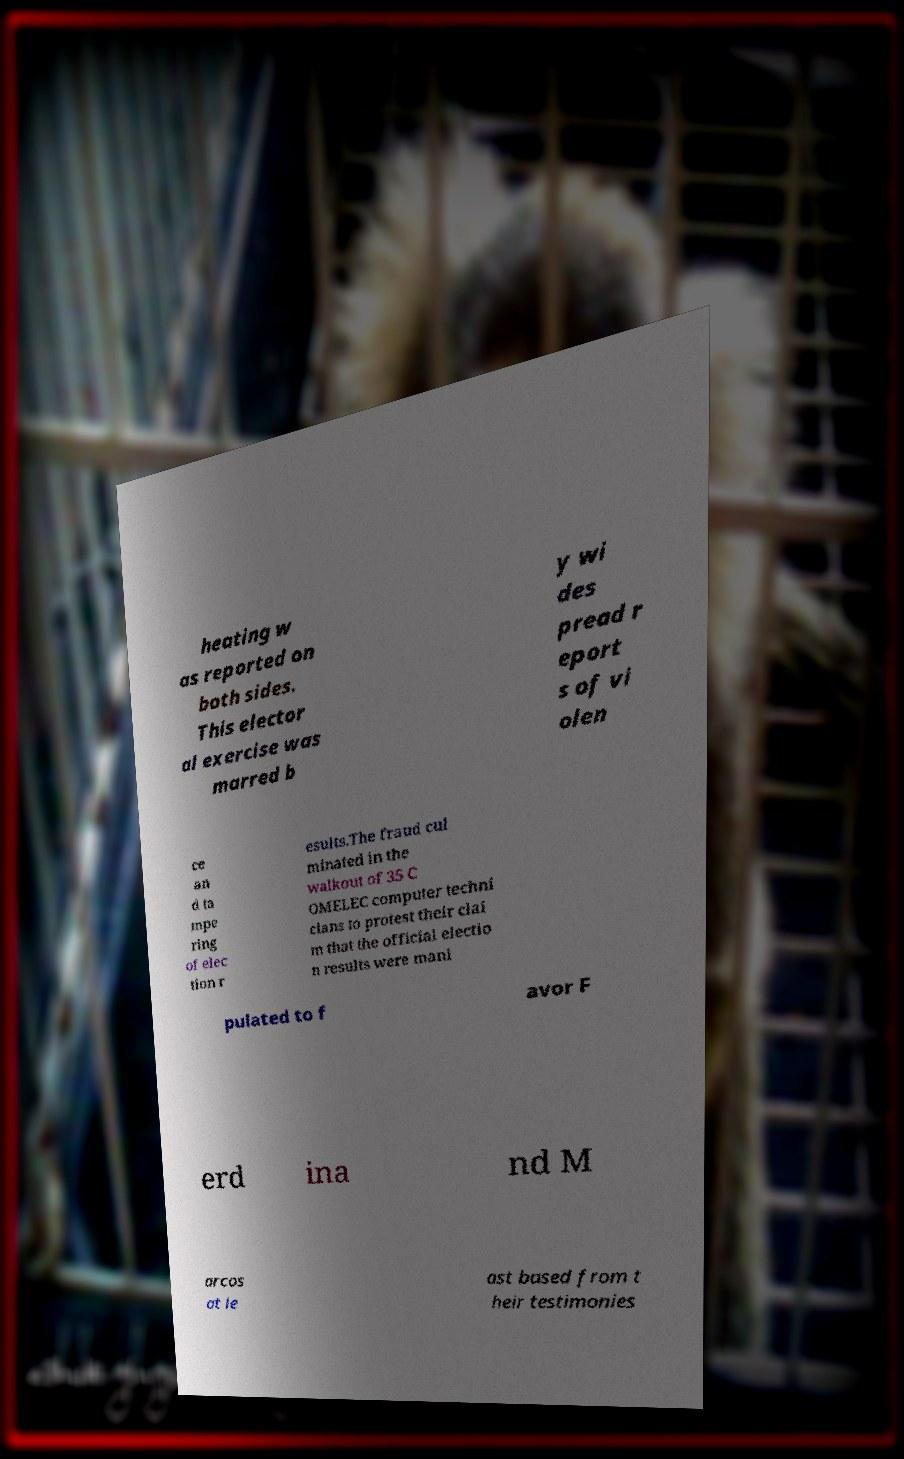Can you accurately transcribe the text from the provided image for me? heating w as reported on both sides. This elector al exercise was marred b y wi des pread r eport s of vi olen ce an d ta mpe ring of elec tion r esults.The fraud cul minated in the walkout of 35 C OMELEC computer techni cians to protest their clai m that the official electio n results were mani pulated to f avor F erd ina nd M arcos at le ast based from t heir testimonies 